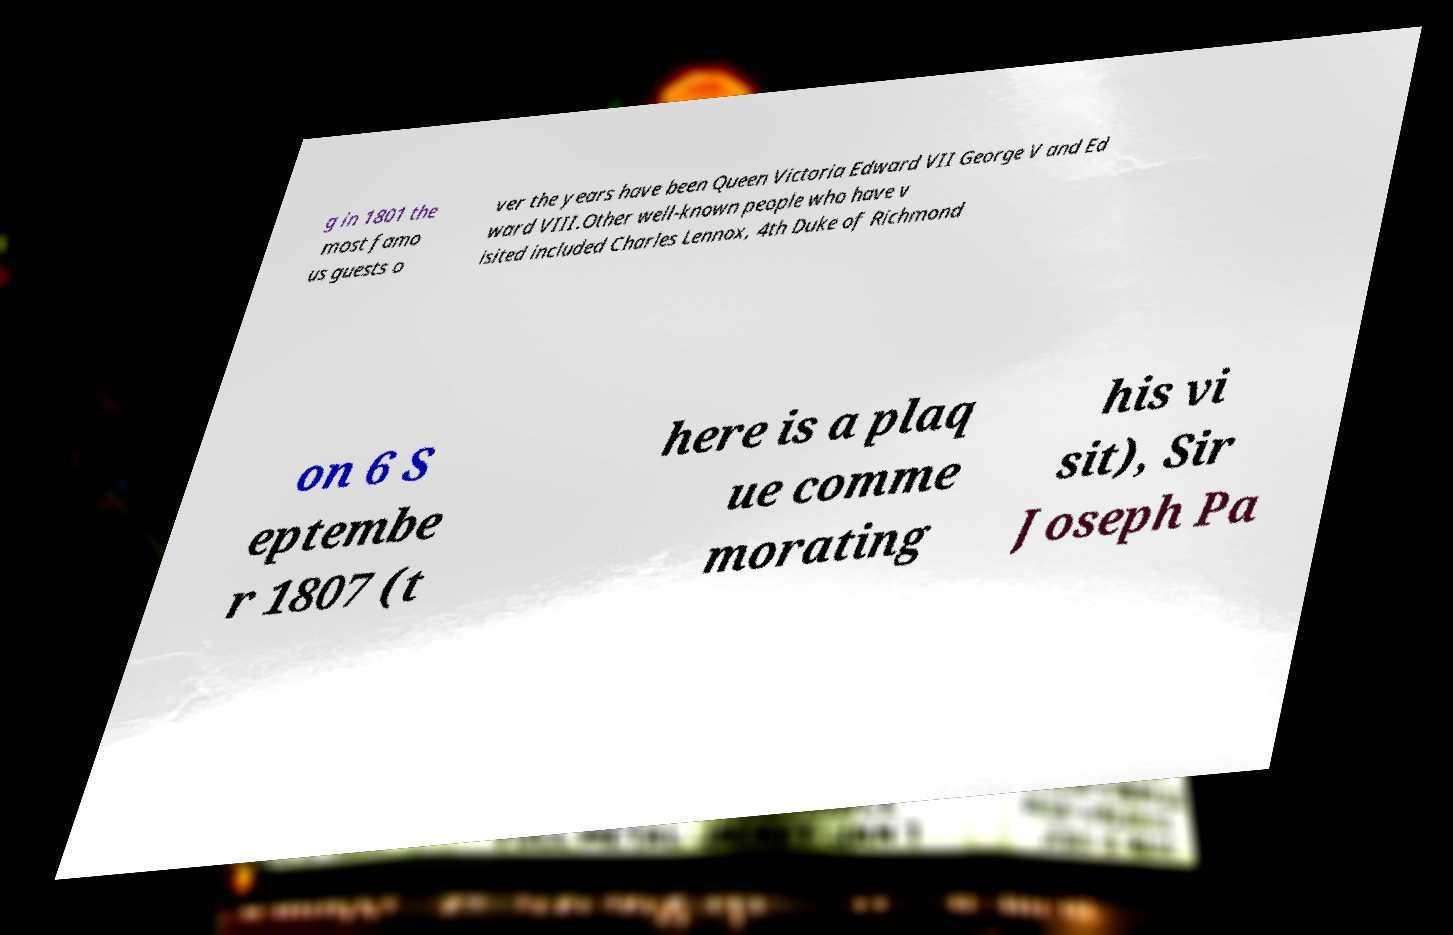Can you accurately transcribe the text from the provided image for me? g in 1801 the most famo us guests o ver the years have been Queen Victoria Edward VII George V and Ed ward VIII.Other well-known people who have v isited included Charles Lennox, 4th Duke of Richmond on 6 S eptembe r 1807 (t here is a plaq ue comme morating his vi sit), Sir Joseph Pa 